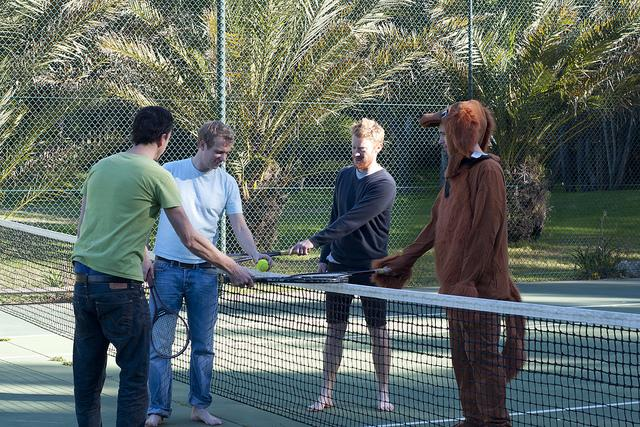Which one is inappropriately dressed? costume 